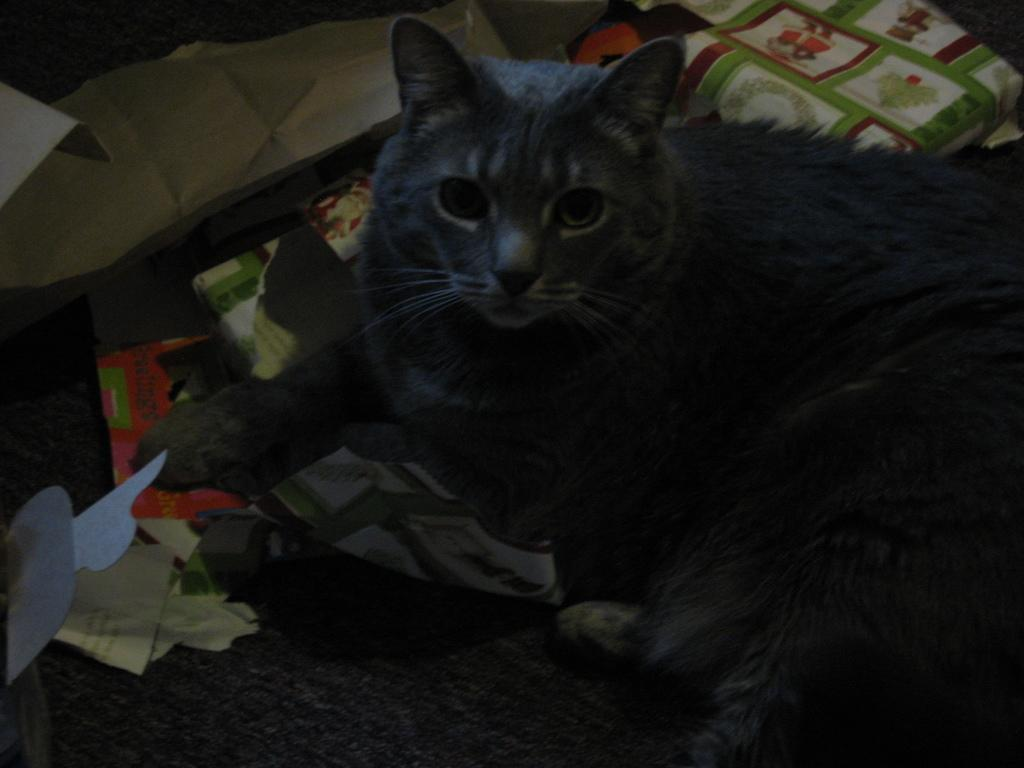What animal is present in the picture? There is a cat in the picture. What is the cat sitting on? The cat is sitting on a cloth. What is the cat's focus in the picture? The cat is looking at someone. How many goldfish are swimming in the bushes in the picture? There are no goldfish or bushes present in the image; it features a cat sitting on a cloth and looking at someone. 